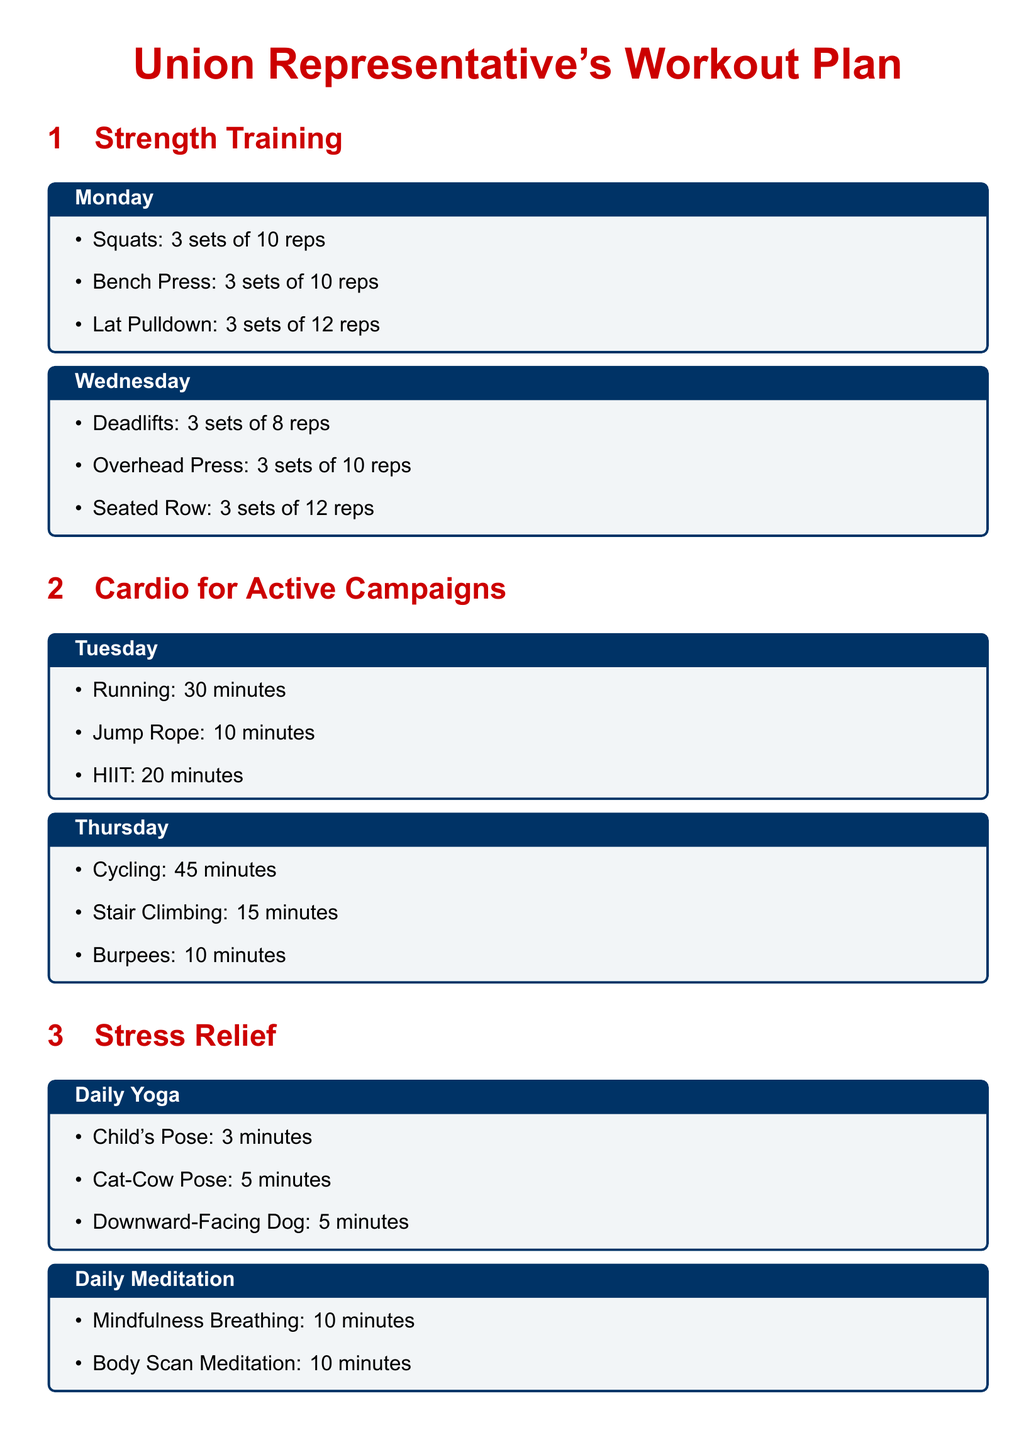What exercises are included in the strength training plan? The strength training plan includes squats, bench press, and lat pulldown on Monday, and deadlifts, overhead press, and seated row on Wednesday.
Answer: Squats, bench press, lat pulldown, deadlifts, overhead press, seated row How many sets of push-ups are included in the weekend warrior plan? The weekend warrior plan includes 15 push-ups per round for 3 rounds in the full-body circuit.
Answer: 15 What is the duration of the cycling workout? The cycling workout is scheduled for 45 minutes on Thursday.
Answer: 45 minutes Which yoga pose is suggested for daily practice? The document lists Child's Pose, Cat-Cow Pose, and Downward-Facing Dog for daily yoga practice.
Answer: Child's Pose How often should mindfulness breathing be practiced according to the document? Mindfulness breathing should be practiced daily for 10 minutes.
Answer: Daily What type of activities are suggested for Sunday in the weekend warrior plan? The Sunday activities include outdoor activities such as hiking, group sports, or gardening for 60 minutes.
Answer: Outdoor activity How long should the stretching routine last on Sunday? The stretching routine on Sunday should last for 15 minutes.
Answer: 15 minutes What should be done for neck relaxation during office hours? Neck stretches for 2 minutes are recommended for relaxation in the office.
Answer: Neck stretches What type of cardio exercises are included for Tuesday? The cardio exercises for Tuesday include running, jump rope, and HIIT.
Answer: Running, jump rope, HIIT 